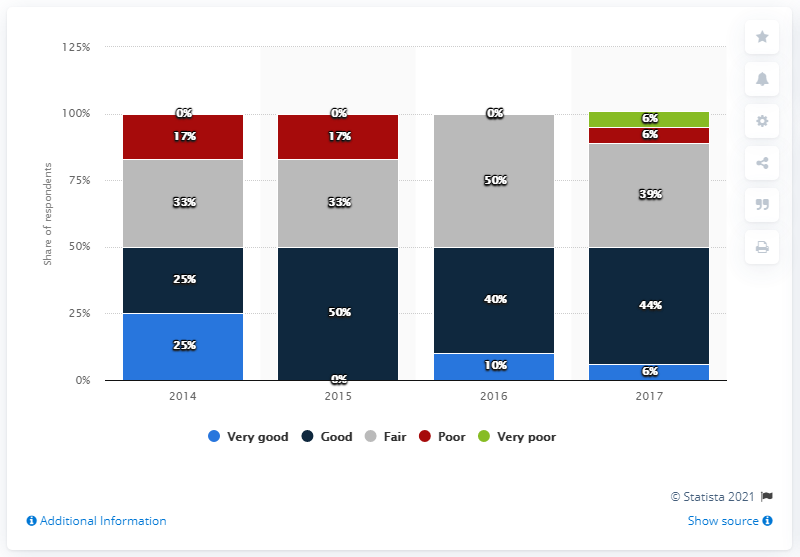Highlight a few significant elements in this photo. In 2016, the respondents reported improved prospects for self-storage facilities. 